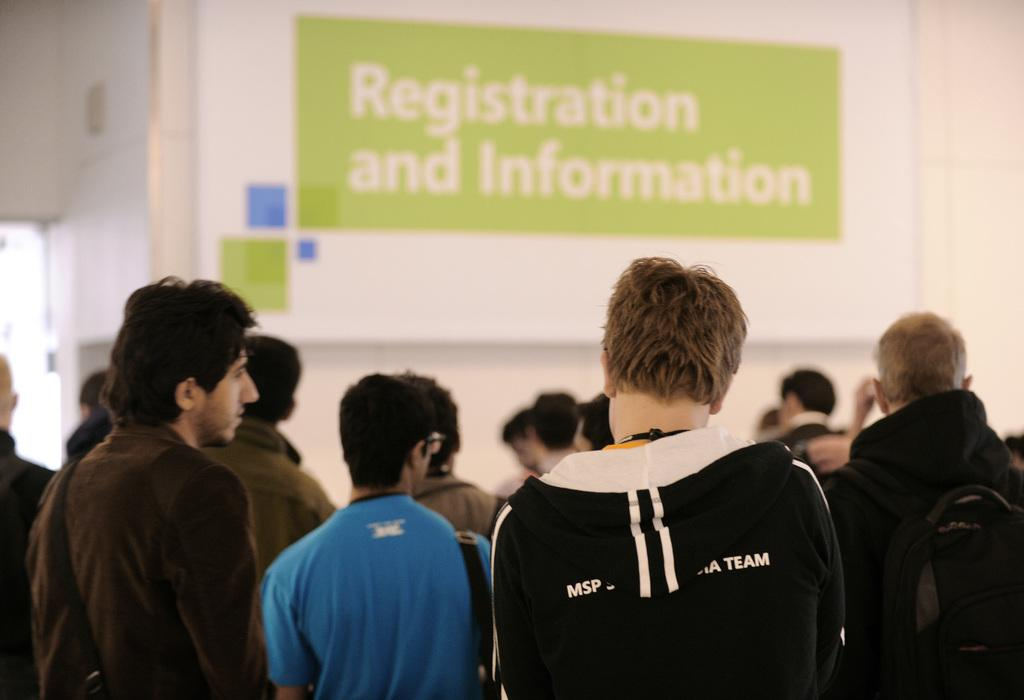What is the main subject of the image? The main subject of the image is a group of people. How are the people dressed in the image? The people are wearing different color dresses in the image. What are the people doing in the image? The people are standing in the image. What can be seen in the background of the image? There is a banner in the background of the image. Where is the banner located in the image? The banner is attached to a wall in the image. What type of meat is being served at the event depicted in the image? There is no indication of any meat or event in the image; it primarily features a group of people standing and wearing different color dresses, along with a banner in the background. 